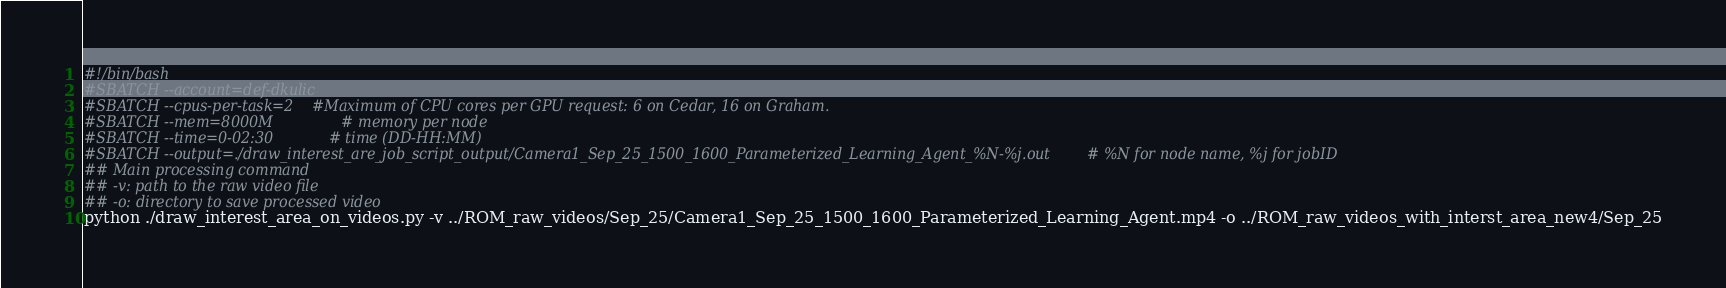Convert code to text. <code><loc_0><loc_0><loc_500><loc_500><_Bash_>#!/bin/bash
#SBATCH --account=def-dkulic
#SBATCH --cpus-per-task=2    #Maximum of CPU cores per GPU request: 6 on Cedar, 16 on Graham.
#SBATCH --mem=8000M               # memory per node
#SBATCH --time=0-02:30            # time (DD-HH:MM)
#SBATCH --output=./draw_interest_are_job_script_output/Camera1_Sep_25_1500_1600_Parameterized_Learning_Agent_%N-%j.out        # %N for node name, %j for jobID
## Main processing command
## -v: path to the raw video file
## -o: directory to save processed video
python ./draw_interest_area_on_videos.py -v ../ROM_raw_videos/Sep_25/Camera1_Sep_25_1500_1600_Parameterized_Learning_Agent.mp4 -o ../ROM_raw_videos_with_interst_area_new4/Sep_25
</code> 